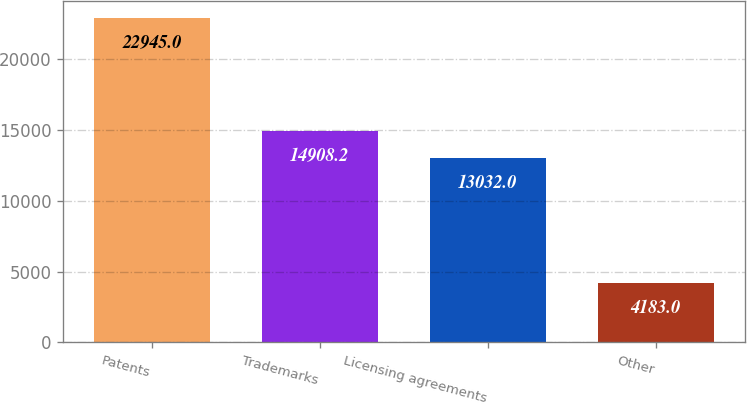Convert chart to OTSL. <chart><loc_0><loc_0><loc_500><loc_500><bar_chart><fcel>Patents<fcel>Trademarks<fcel>Licensing agreements<fcel>Other<nl><fcel>22945<fcel>14908.2<fcel>13032<fcel>4183<nl></chart> 